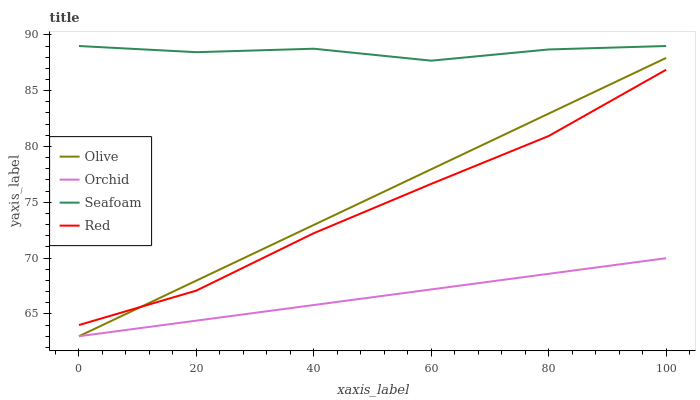Does Red have the minimum area under the curve?
Answer yes or no. No. Does Red have the maximum area under the curve?
Answer yes or no. No. Is Red the smoothest?
Answer yes or no. No. Is Red the roughest?
Answer yes or no. No. Does Red have the lowest value?
Answer yes or no. No. Does Red have the highest value?
Answer yes or no. No. Is Orchid less than Red?
Answer yes or no. Yes. Is Seafoam greater than Red?
Answer yes or no. Yes. Does Orchid intersect Red?
Answer yes or no. No. 